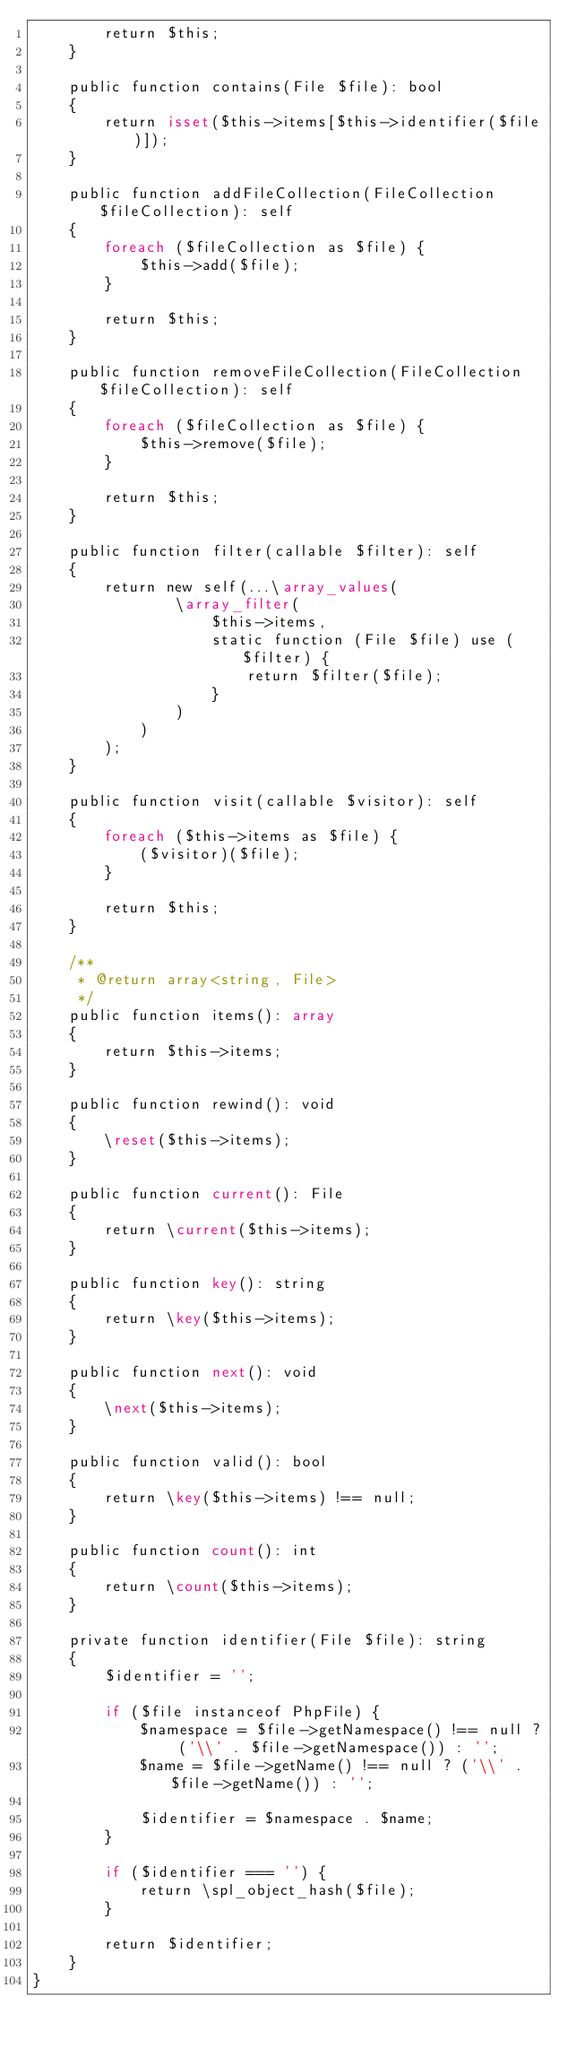<code> <loc_0><loc_0><loc_500><loc_500><_PHP_>        return $this;
    }

    public function contains(File $file): bool
    {
        return isset($this->items[$this->identifier($file)]);
    }

    public function addFileCollection(FileCollection $fileCollection): self
    {
        foreach ($fileCollection as $file) {
            $this->add($file);
        }

        return $this;
    }

    public function removeFileCollection(FileCollection $fileCollection): self
    {
        foreach ($fileCollection as $file) {
            $this->remove($file);
        }

        return $this;
    }

    public function filter(callable $filter): self
    {
        return new self(...\array_values(
                \array_filter(
                    $this->items,
                    static function (File $file) use ($filter) {
                        return $filter($file);
                    }
                )
            )
        );
    }

    public function visit(callable $visitor): self
    {
        foreach ($this->items as $file) {
            ($visitor)($file);
        }

        return $this;
    }

    /**
     * @return array<string, File>
     */
    public function items(): array
    {
        return $this->items;
    }

    public function rewind(): void
    {
        \reset($this->items);
    }

    public function current(): File
    {
        return \current($this->items);
    }

    public function key(): string
    {
        return \key($this->items);
    }

    public function next(): void
    {
        \next($this->items);
    }

    public function valid(): bool
    {
        return \key($this->items) !== null;
    }

    public function count(): int
    {
        return \count($this->items);
    }

    private function identifier(File $file): string
    {
        $identifier = '';

        if ($file instanceof PhpFile) {
            $namespace = $file->getNamespace() !== null ? ('\\' . $file->getNamespace()) : '';
            $name = $file->getName() !== null ? ('\\' . $file->getName()) : '';

            $identifier = $namespace . $name;
        }

        if ($identifier === '') {
            return \spl_object_hash($file);
        }

        return $identifier;
    }
}
</code> 